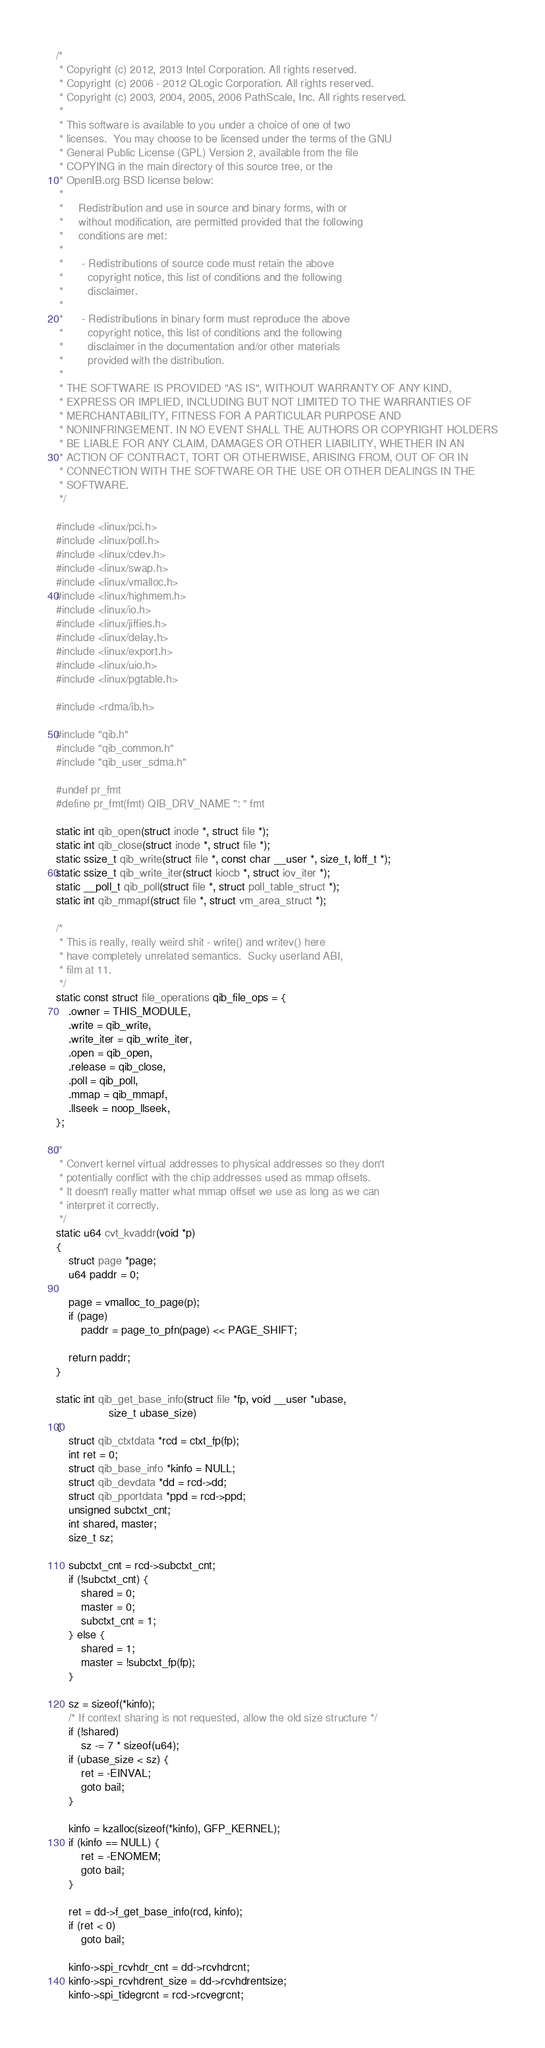Convert code to text. <code><loc_0><loc_0><loc_500><loc_500><_C_>/*
 * Copyright (c) 2012, 2013 Intel Corporation. All rights reserved.
 * Copyright (c) 2006 - 2012 QLogic Corporation. All rights reserved.
 * Copyright (c) 2003, 2004, 2005, 2006 PathScale, Inc. All rights reserved.
 *
 * This software is available to you under a choice of one of two
 * licenses.  You may choose to be licensed under the terms of the GNU
 * General Public License (GPL) Version 2, available from the file
 * COPYING in the main directory of this source tree, or the
 * OpenIB.org BSD license below:
 *
 *     Redistribution and use in source and binary forms, with or
 *     without modification, are permitted provided that the following
 *     conditions are met:
 *
 *      - Redistributions of source code must retain the above
 *        copyright notice, this list of conditions and the following
 *        disclaimer.
 *
 *      - Redistributions in binary form must reproduce the above
 *        copyright notice, this list of conditions and the following
 *        disclaimer in the documentation and/or other materials
 *        provided with the distribution.
 *
 * THE SOFTWARE IS PROVIDED "AS IS", WITHOUT WARRANTY OF ANY KIND,
 * EXPRESS OR IMPLIED, INCLUDING BUT NOT LIMITED TO THE WARRANTIES OF
 * MERCHANTABILITY, FITNESS FOR A PARTICULAR PURPOSE AND
 * NONINFRINGEMENT. IN NO EVENT SHALL THE AUTHORS OR COPYRIGHT HOLDERS
 * BE LIABLE FOR ANY CLAIM, DAMAGES OR OTHER LIABILITY, WHETHER IN AN
 * ACTION OF CONTRACT, TORT OR OTHERWISE, ARISING FROM, OUT OF OR IN
 * CONNECTION WITH THE SOFTWARE OR THE USE OR OTHER DEALINGS IN THE
 * SOFTWARE.
 */

#include <linux/pci.h>
#include <linux/poll.h>
#include <linux/cdev.h>
#include <linux/swap.h>
#include <linux/vmalloc.h>
#include <linux/highmem.h>
#include <linux/io.h>
#include <linux/jiffies.h>
#include <linux/delay.h>
#include <linux/export.h>
#include <linux/uio.h>
#include <linux/pgtable.h>

#include <rdma/ib.h>

#include "qib.h"
#include "qib_common.h"
#include "qib_user_sdma.h"

#undef pr_fmt
#define pr_fmt(fmt) QIB_DRV_NAME ": " fmt

static int qib_open(struct inode *, struct file *);
static int qib_close(struct inode *, struct file *);
static ssize_t qib_write(struct file *, const char __user *, size_t, loff_t *);
static ssize_t qib_write_iter(struct kiocb *, struct iov_iter *);
static __poll_t qib_poll(struct file *, struct poll_table_struct *);
static int qib_mmapf(struct file *, struct vm_area_struct *);

/*
 * This is really, really weird shit - write() and writev() here
 * have completely unrelated semantics.  Sucky userland ABI,
 * film at 11.
 */
static const struct file_operations qib_file_ops = {
	.owner = THIS_MODULE,
	.write = qib_write,
	.write_iter = qib_write_iter,
	.open = qib_open,
	.release = qib_close,
	.poll = qib_poll,
	.mmap = qib_mmapf,
	.llseek = noop_llseek,
};

/*
 * Convert kernel virtual addresses to physical addresses so they don't
 * potentially conflict with the chip addresses used as mmap offsets.
 * It doesn't really matter what mmap offset we use as long as we can
 * interpret it correctly.
 */
static u64 cvt_kvaddr(void *p)
{
	struct page *page;
	u64 paddr = 0;

	page = vmalloc_to_page(p);
	if (page)
		paddr = page_to_pfn(page) << PAGE_SHIFT;

	return paddr;
}

static int qib_get_base_info(struct file *fp, void __user *ubase,
			     size_t ubase_size)
{
	struct qib_ctxtdata *rcd = ctxt_fp(fp);
	int ret = 0;
	struct qib_base_info *kinfo = NULL;
	struct qib_devdata *dd = rcd->dd;
	struct qib_pportdata *ppd = rcd->ppd;
	unsigned subctxt_cnt;
	int shared, master;
	size_t sz;

	subctxt_cnt = rcd->subctxt_cnt;
	if (!subctxt_cnt) {
		shared = 0;
		master = 0;
		subctxt_cnt = 1;
	} else {
		shared = 1;
		master = !subctxt_fp(fp);
	}

	sz = sizeof(*kinfo);
	/* If context sharing is not requested, allow the old size structure */
	if (!shared)
		sz -= 7 * sizeof(u64);
	if (ubase_size < sz) {
		ret = -EINVAL;
		goto bail;
	}

	kinfo = kzalloc(sizeof(*kinfo), GFP_KERNEL);
	if (kinfo == NULL) {
		ret = -ENOMEM;
		goto bail;
	}

	ret = dd->f_get_base_info(rcd, kinfo);
	if (ret < 0)
		goto bail;

	kinfo->spi_rcvhdr_cnt = dd->rcvhdrcnt;
	kinfo->spi_rcvhdrent_size = dd->rcvhdrentsize;
	kinfo->spi_tidegrcnt = rcd->rcvegrcnt;</code> 